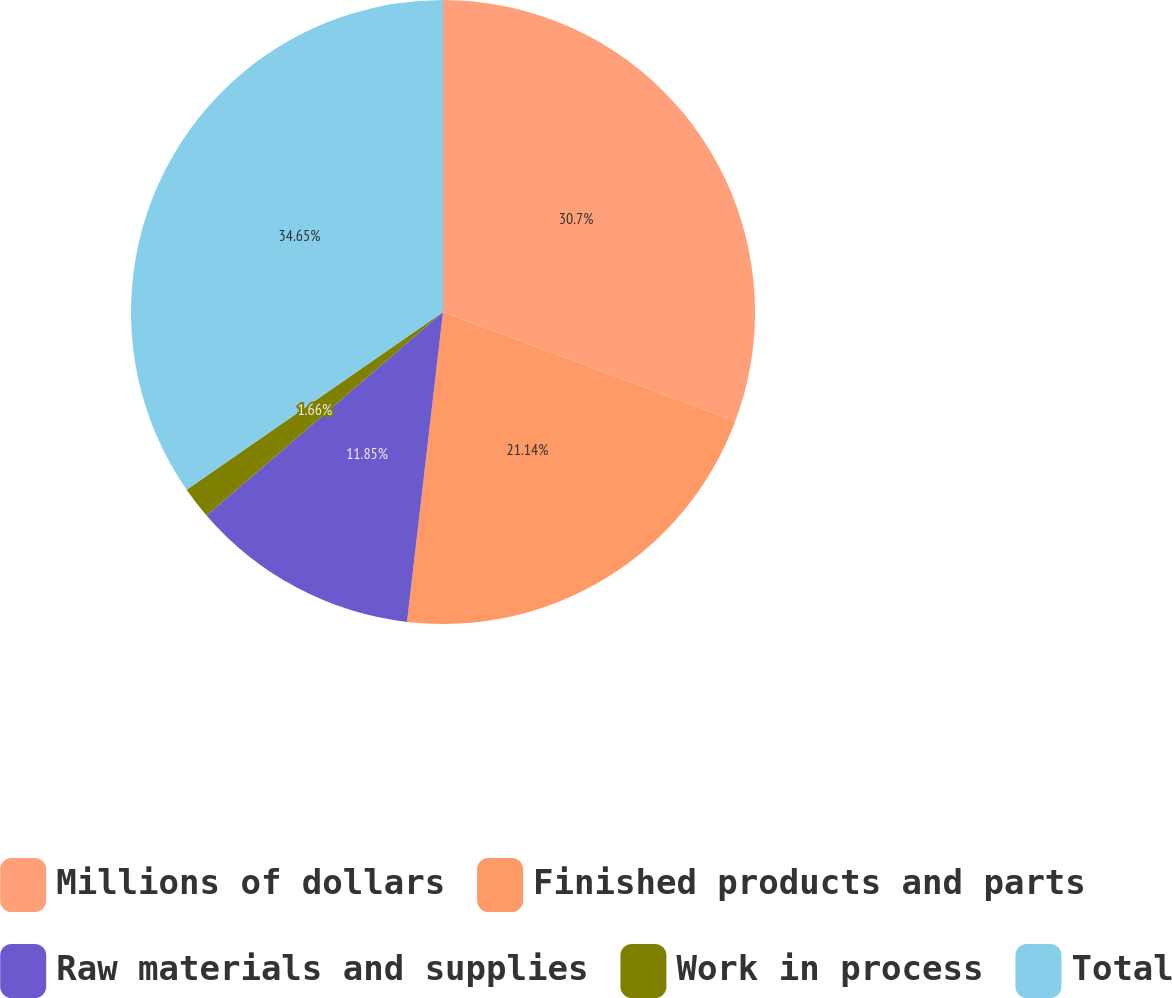<chart> <loc_0><loc_0><loc_500><loc_500><pie_chart><fcel>Millions of dollars<fcel>Finished products and parts<fcel>Raw materials and supplies<fcel>Work in process<fcel>Total<nl><fcel>30.7%<fcel>21.14%<fcel>11.85%<fcel>1.66%<fcel>34.65%<nl></chart> 